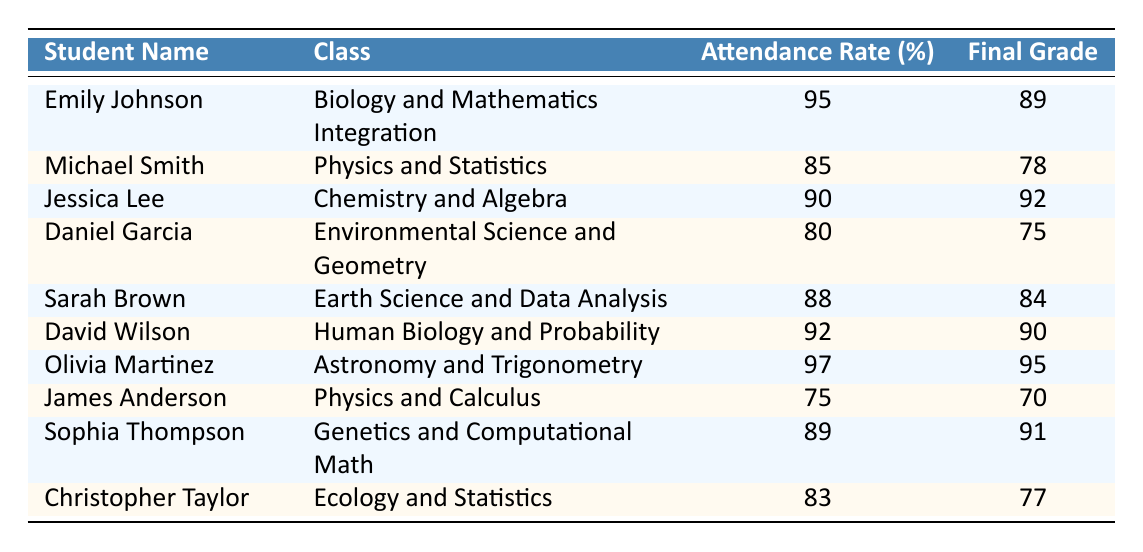What is the attendance rate of Jessica Lee? The table shows Jessica Lee's attendance rate listed in the corresponding row. Her attendance rate is 90%.
Answer: 90% Which student has the highest attendance rate? By examining the attendance rates in the table, Olivia Martinez has the highest attendance rate at 97%.
Answer: 97% What is the final grade of David Wilson? Looking at the table, David Wilson's final grade can be found in his row, which shows that his final grade is 90.
Answer: 90 How many students have an attendance rate of 85% or higher? To find this, count the number of students with attendance rates of 85% or higher. The students are Emily Johnson, Michael Smith, Jessica Lee, Sarah Brown, David Wilson, Olivia Martinez, and Sophia Thompson, totaling 7 students.
Answer: 7 What is the average final grade of all students? First, sum the final grades of all students: 89 + 78 + 92 + 75 + 84 + 90 + 95 + 70 + 91 + 77 = 900. Then divide by the number of students, which is 10: 900 / 10 = 90.
Answer: 90 Is there a correlation between attendance rates and final grades for the students listed? To determine this, look for students with high attendance rates and their corresponding final grades. High attendance rates generally correspond to higher grades, suggesting a positive correlation.
Answer: Yes What is the difference between the highest and lowest final grades? The highest final grade is 95 (Olivia Martinez), and the lowest final grade is 70 (James Anderson). Calculate the difference: 95 - 70 = 25.
Answer: 25 Which student has the lowest attendance rate? The student with the lowest attendance rate is James Anderson, whose attendance rate is 75%.
Answer: 75% Does any student have an attendance rate higher than 90% and a final grade below 90? Checking the table, Michael Smith has an attendance rate of 85% but does not qualify. Daniel Garcia has a rate of 80%. Since all students with above 90% attendance are above 90% in grades, the answer is no.
Answer: No What is the median attendance rate of the students? First, arrange the attendance rates in numerical order: 75, 80, 83, 85, 88, 89, 90, 92, 95, 97. The median is the average of the 5th and 6th values (88 and 89): (88 + 89) / 2 = 88.5.
Answer: 88.5 Calculate the percentage of students who scored above 80 in their final grades. Analyzing the table, the students scoring above 80 are Emily Johnson, Jessica Lee, Sarah Brown, David Wilson, Olivia Martinez, Sophia Thompson. That totals to 6 students out of 10. Thus, the percentage is (6/10) * 100 = 60%.
Answer: 60% 